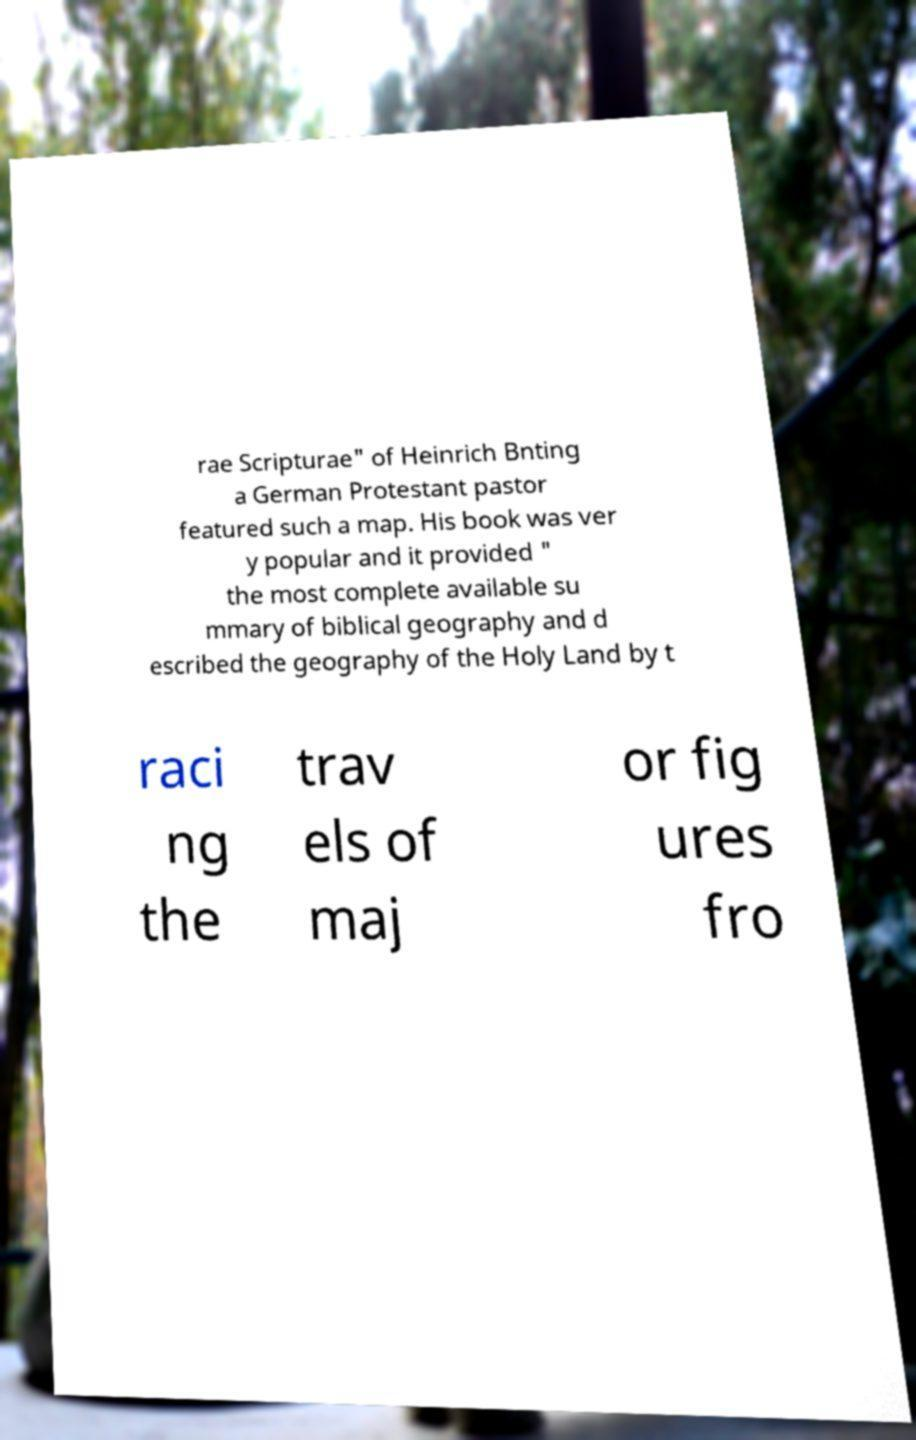Can you read and provide the text displayed in the image?This photo seems to have some interesting text. Can you extract and type it out for me? rae Scripturae" of Heinrich Bnting a German Protestant pastor featured such a map. His book was ver y popular and it provided " the most complete available su mmary of biblical geography and d escribed the geography of the Holy Land by t raci ng the trav els of maj or fig ures fro 